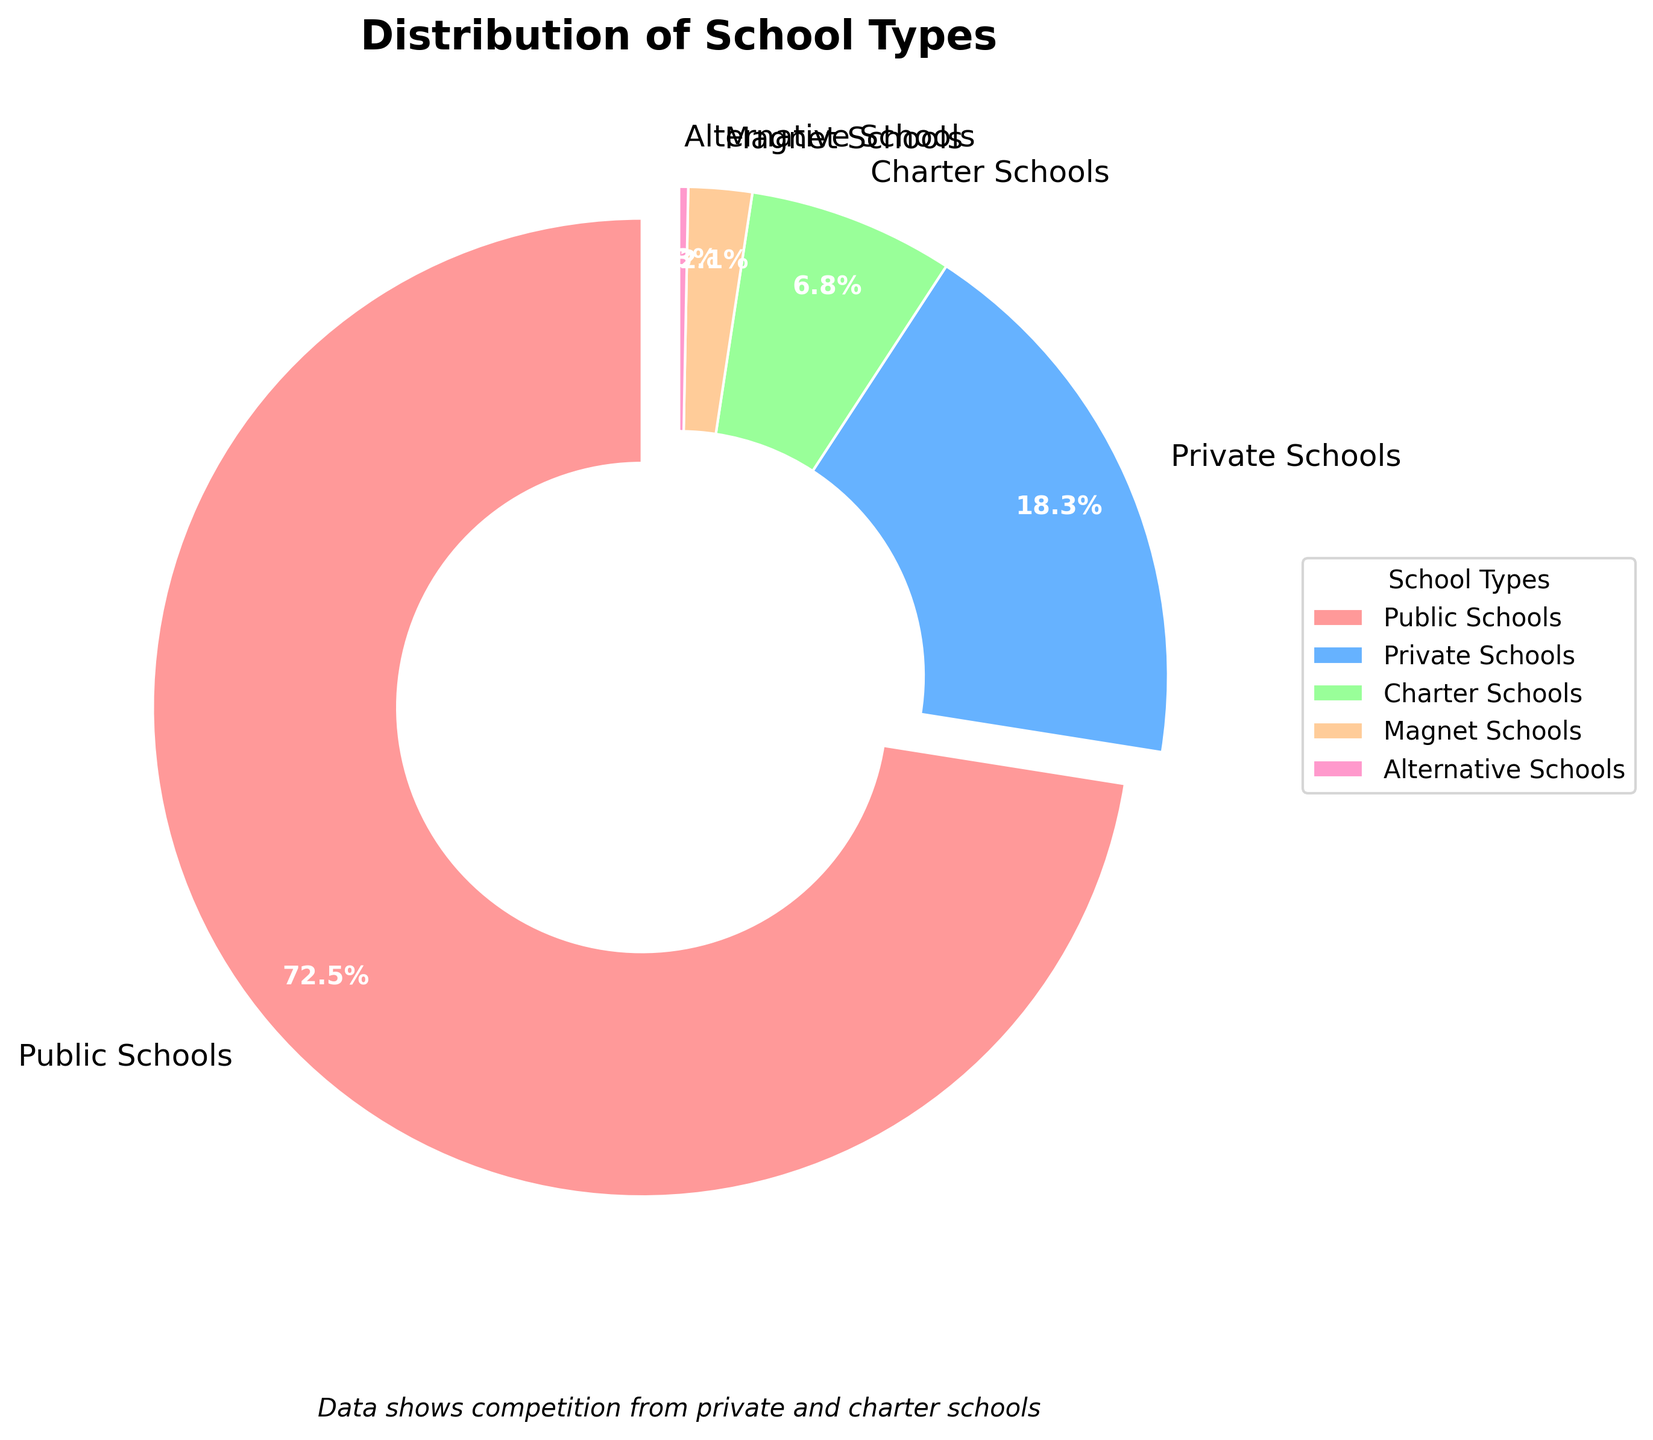Which school type has the highest percentage? The figure shows that Public Schools have the largest segment in the pie chart.
Answer: Public Schools Which school type has the smallest percentage? The pie chart indicates that Alternative Schools have the smallest segment, representing only 0.3%.
Answer: Alternative Schools What is the combined percentage of Private and Charter Schools? Add the percentages for Private Schools (18.3%) and Charter Schools (6.8%). 18.3 + 6.8 = 25.1
Answer: 25.1 Which school types have a percentage of less than 10%? From the pie chart, Private, Charter, Magnet, and Alternative Schools all have segments representing less than 10%.
Answer: Private Schools, Charter Schools, Magnet Schools, Alternative Schools Are there more Private Schools or Charter Schools? The segment for Private Schools is larger than that for Charter Schools. Private Schools have 18.3% compared to 6.8% for Charter Schools.
Answer: Private Schools By how much percentage do Public Schools exceed Private Schools? Subtract the percentage of Private Schools (18.3%) from Public Schools (72.5%). 72.5 - 18.3 = 54.2
Answer: 54.2 Which school types are represented by less than 5% each? The pie chart shows that Magnet Schools (2.1%) and Alternative Schools (0.3%) both have segments less than 5%.
Answer: Magnet Schools, Alternative Schools How does the percentage of Charter Schools compare to Magnet Schools? The segment for Charter Schools is larger than that of Magnet Schools, with Charter Schools at 6.8% and Magnet Schools at 2.1%.
Answer: Charter Schools are greater than Magnet Schools What does the subtitle of the chart indicate about the data? The subtitle reads, "Data shows competition from private and charter schools," suggesting that these school types influence the others.
Answer: Competition from private and charter schools If Public Schools' percentage was reduced by half, what would it be? Divide the percentage of Public Schools (72.5%) by 2. 72.5 / 2 = 36.25
Answer: 36.25 